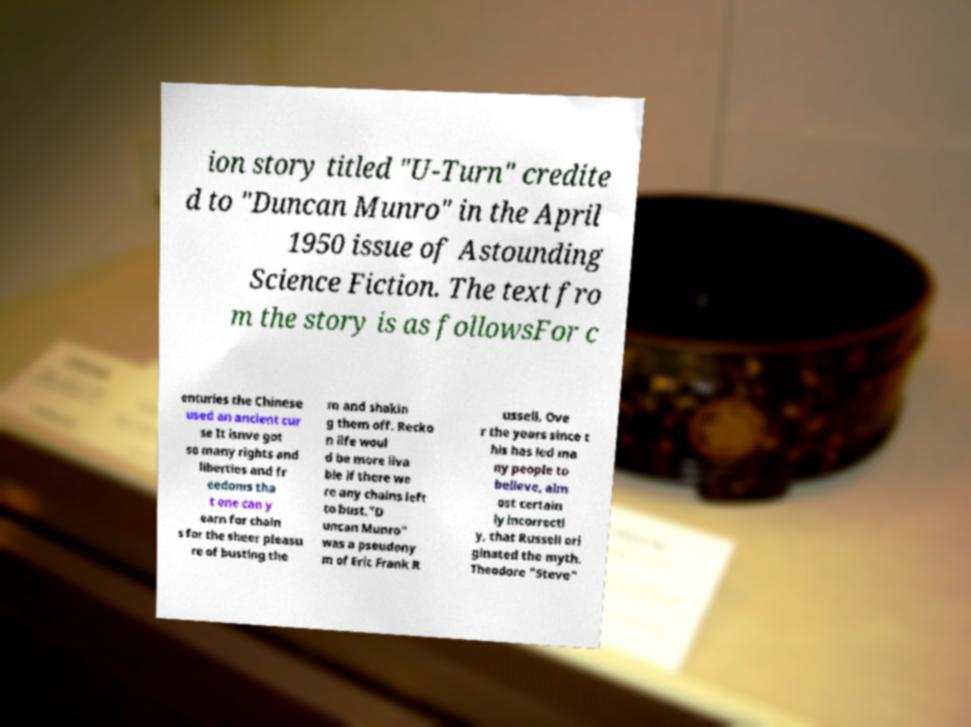Could you extract and type out the text from this image? ion story titled "U-Turn" credite d to "Duncan Munro" in the April 1950 issue of Astounding Science Fiction. The text fro m the story is as followsFor c enturies the Chinese used an ancient cur se It isnve got so many rights and liberties and fr eedoms tha t one can y earn for chain s for the sheer pleasu re of busting the m and shakin g them off. Recko n life woul d be more liva ble if there we re any chains left to bust."D uncan Munro" was a pseudony m of Eric Frank R ussell, Ove r the years since t his has led ma ny people to believe, alm ost certain ly incorrectl y, that Russell ori ginated the myth. Theodore "Steve" 